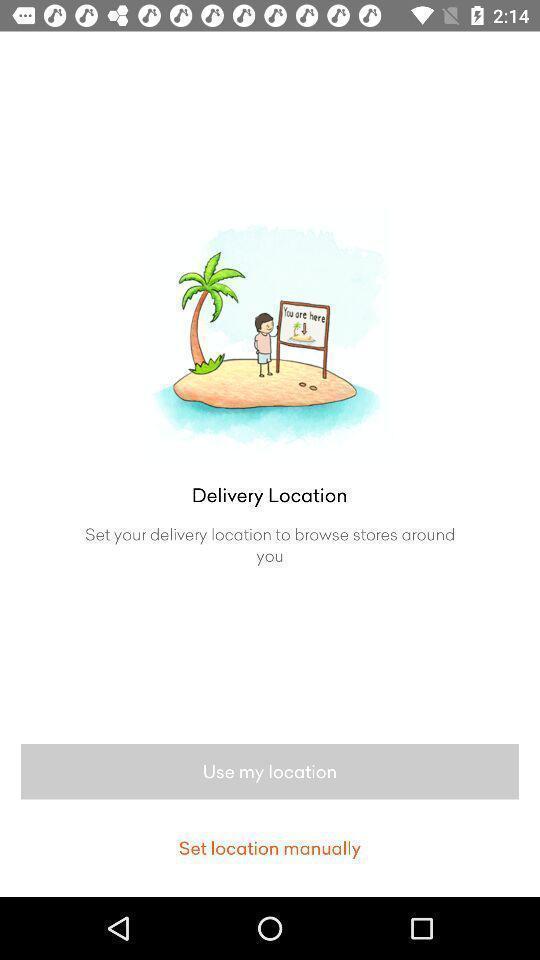Tell me about the visual elements in this screen capture. Screen showing set your delivery location. 